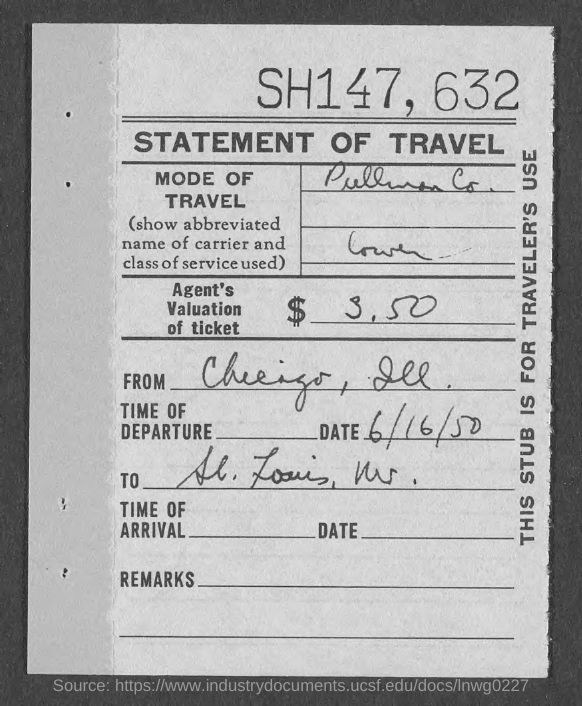What is Valuation of Ticket?
Provide a succinct answer. 3.50. Date of Depature?
Your response must be concise. 6/16/50. 